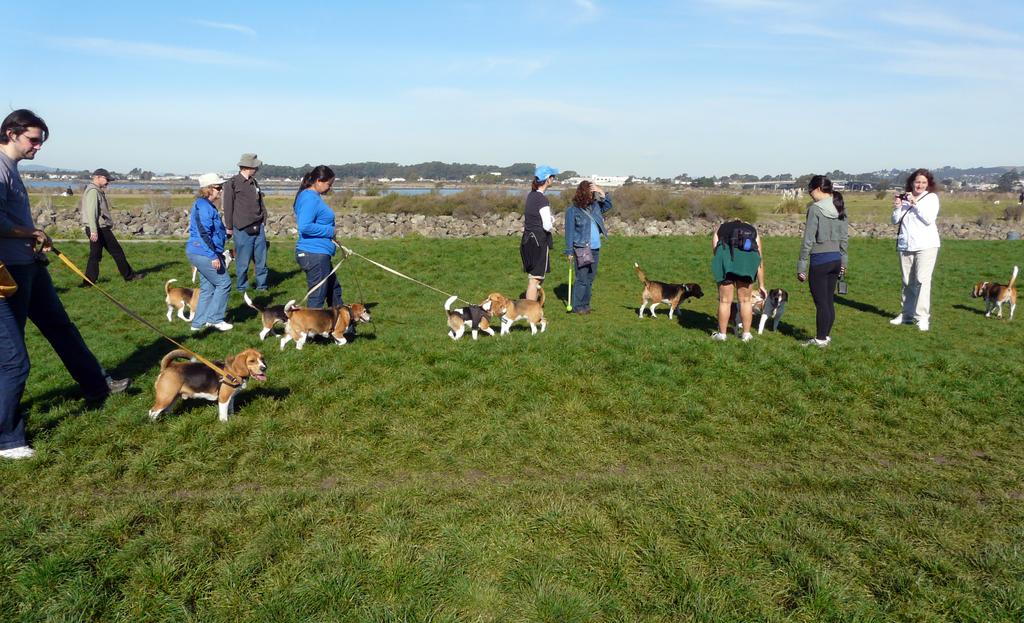Who or what can be seen in the image? There are people and dogs in the image. Where are the people and dogs located? They are on the grass in the image. What other elements can be seen in the image? There are stones, water, trees, buildings, and the sky visible in the image. What type of spoon is being used by the father in the image? There is no father or spoon present in the image. What kind of shoes are the people wearing in the image? The image does not show the people's shoes, so it cannot be determined from the image. 